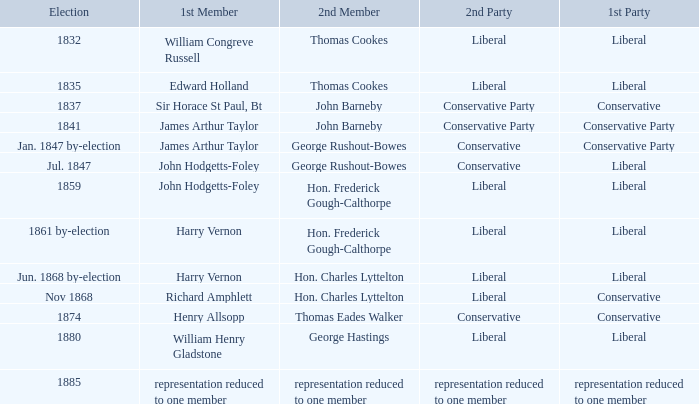What was the 2nd Party that had the 2nd Member John Barneby, when the 1st Party was Conservative? Conservative Party. 